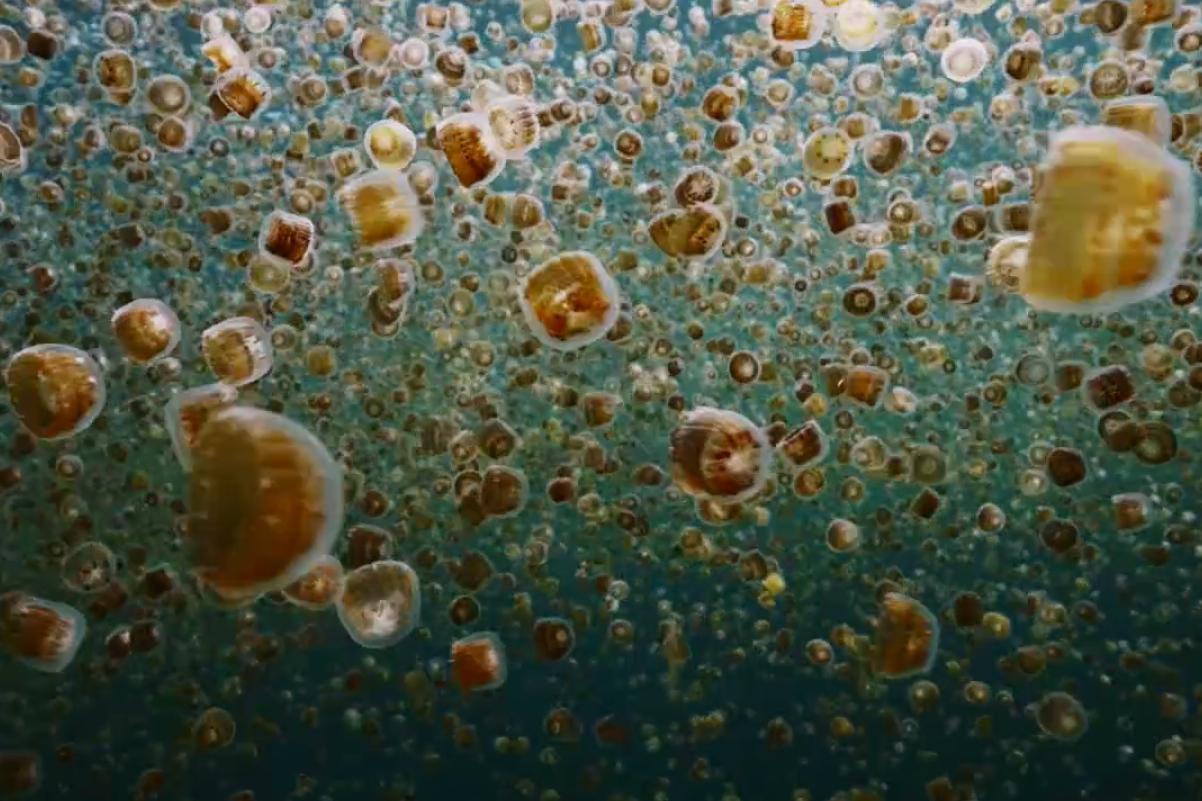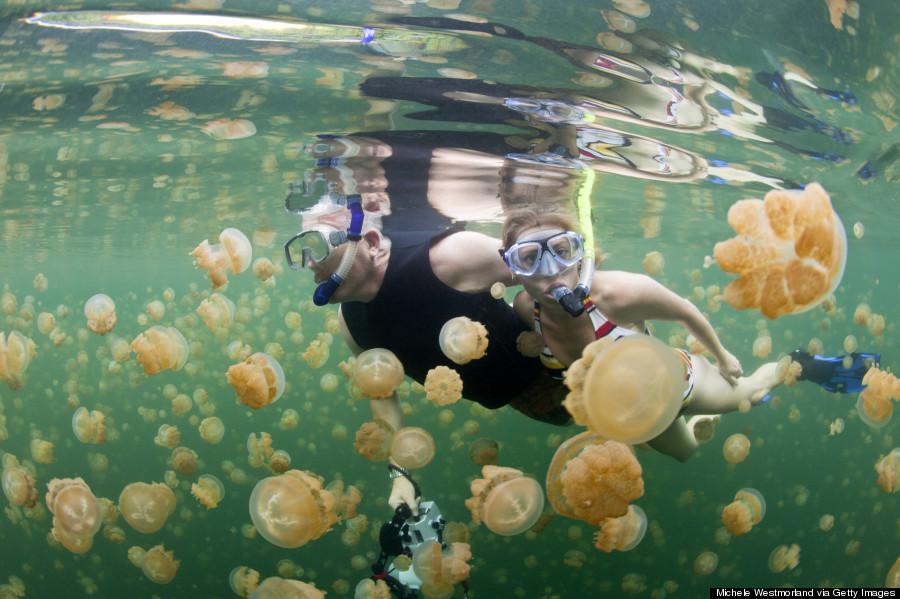The first image is the image on the left, the second image is the image on the right. Evaluate the accuracy of this statement regarding the images: "There is at least one person in the image on the right". Is it true? Answer yes or no. Yes. 